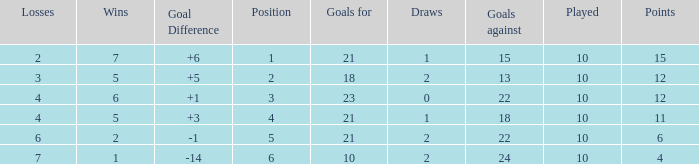Can you tell me the sum of Goals against that has the Goals for larger than 10, and the Position of 3, and the Wins smaller than 6? None. Can you give me this table as a dict? {'header': ['Losses', 'Wins', 'Goal Difference', 'Position', 'Goals for', 'Draws', 'Goals against', 'Played', 'Points'], 'rows': [['2', '7', '+6', '1', '21', '1', '15', '10', '15'], ['3', '5', '+5', '2', '18', '2', '13', '10', '12'], ['4', '6', '+1', '3', '23', '0', '22', '10', '12'], ['4', '5', '+3', '4', '21', '1', '18', '10', '11'], ['6', '2', '-1', '5', '21', '2', '22', '10', '6'], ['7', '1', '-14', '6', '10', '2', '24', '10', '4']]} 